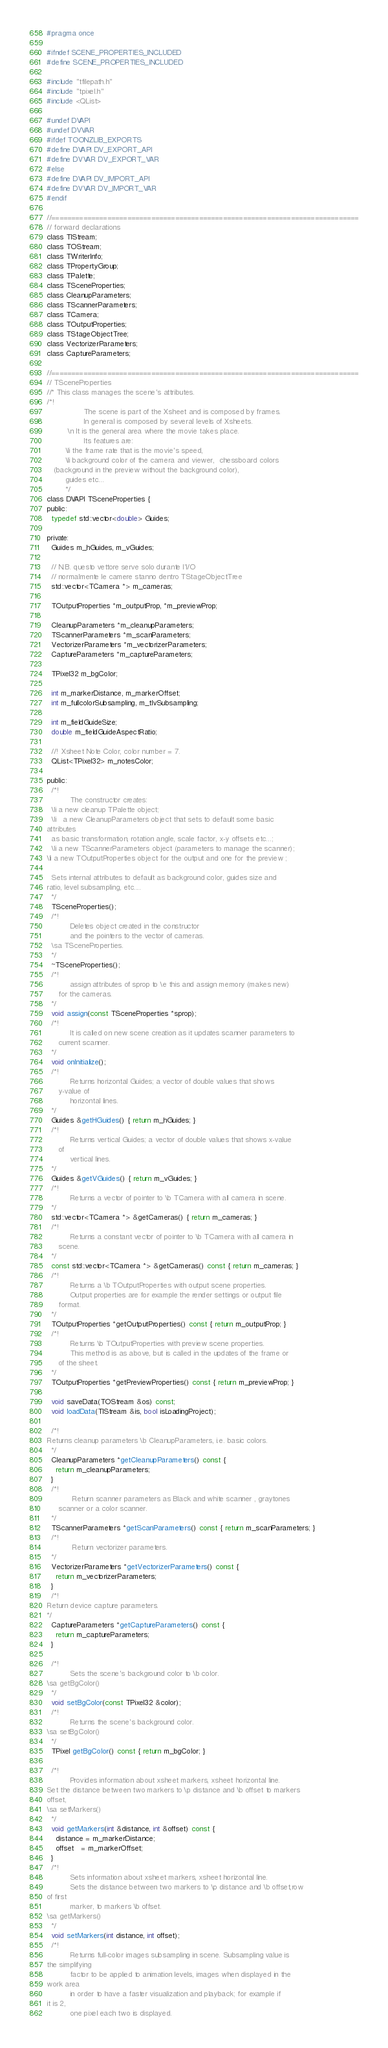Convert code to text. <code><loc_0><loc_0><loc_500><loc_500><_C_>#pragma once

#ifndef SCENE_PROPERTIES_INCLUDED
#define SCENE_PROPERTIES_INCLUDED

#include "tfilepath.h"
#include "tpixel.h"
#include <QList>

#undef DVAPI
#undef DVVAR
#ifdef TOONZLIB_EXPORTS
#define DVAPI DV_EXPORT_API
#define DVVAR DV_EXPORT_VAR
#else
#define DVAPI DV_IMPORT_API
#define DVVAR DV_IMPORT_VAR
#endif

//=============================================================================
// forward declarations
class TIStream;
class TOStream;
class TWriterInfo;
class TPropertyGroup;
class TPalette;
class TSceneProperties;
class CleanupParameters;
class TScannerParameters;
class TCamera;
class TOutputProperties;
class TStageObjectTree;
class VectorizerParameters;
class CaptureParameters;

//=============================================================================
// TSceneProperties
//* This class manages the scene's attributes.
/*!
                The scene is part of the Xsheet and is composed by frames.
                In general is composed by several levels of Xsheets.
         \n	It is the general area where the movie takes place.
                Its features are:
        \li the frame rate that is the movie's speed,
        \li background color of the camera and viewer,  chessboard colors
   (background in the preview without the background color),
        guides etc...
        */
class DVAPI TSceneProperties {
public:
  typedef std::vector<double> Guides;

private:
  Guides m_hGuides, m_vGuides;

  // N.B. questo vettore serve solo durante l'I/O
  // normalmente le camere stanno dentro TStageObjectTree
  std::vector<TCamera *> m_cameras;

  TOutputProperties *m_outputProp, *m_previewProp;

  CleanupParameters *m_cleanupParameters;
  TScannerParameters *m_scanParameters;
  VectorizerParameters *m_vectorizerParameters;
  CaptureParameters *m_captureParameters;

  TPixel32 m_bgColor;

  int m_markerDistance, m_markerOffset;
  int m_fullcolorSubsampling, m_tlvSubsampling;

  int m_fieldGuideSize;
  double m_fieldGuideAspectRatio;

  //! Xsheet Note Color, color number = 7.
  QList<TPixel32> m_notesColor;

public:
  /*!
          The constructor creates:
  \li a new cleanup TPalette object;
  \li	a new CleanupParameters object that sets to default some basic
attributes
  as basic transformation, rotation angle, scale factor, x-y offsets etc...;
  \li a new TScannerParameters object (parameters to manage the scanner);
\li a new TOutputProperties object for the output and one for the preview ;

  Sets internal attributes to default as background color, guides size and
ratio, level subsampling, etc....
  */
  TSceneProperties();
  /*!
          Deletes object created in the constructor
          and the pointers to the vector of cameras.
  \sa TSceneProperties.
  */
  ~TSceneProperties();
  /*!
          assign attributes of sprop to \e this and assign memory (makes new)
     for the cameras.
  */
  void assign(const TSceneProperties *sprop);
  /*!
          It is called on new scene creation as it updates scanner parameters to
     current scanner.
  */
  void onInitialize();
  /*!
          Returns horizontal Guides; a vector of double values that shows
     y-value of
          horizontal lines.
  */
  Guides &getHGuides() { return m_hGuides; }
  /*!
          Returns vertical Guides; a vector of double values that shows x-value
     of
          vertical lines.
  */
  Guides &getVGuides() { return m_vGuides; }
  /*!
          Returns a vector of pointer to \b TCamera with all camera in scene.
  */
  std::vector<TCamera *> &getCameras() { return m_cameras; }
  /*!
          Returns a constant vector of pointer to \b TCamera with all camera in
     scene.
  */
  const std::vector<TCamera *> &getCameras() const { return m_cameras; }
  /*!
          Returns a \b TOutputProperties with output scene properties.
          Output properties are for example the render settings or output file
     format.
  */
  TOutputProperties *getOutputProperties() const { return m_outputProp; }
  /*!
          Returns \b TOutputProperties with preview scene properties.
          This method is as above, but is called in the updates of the frame or
     of the sheet.
  */
  TOutputProperties *getPreviewProperties() const { return m_previewProp; }

  void saveData(TOStream &os) const;
  void loadData(TIStream &is, bool isLoadingProject);

  /*!
Returns cleanup parameters \b CleanupParameters, i.e. basic colors.
  */
  CleanupParameters *getCleanupParameters() const {
    return m_cleanupParameters;
  }
  /*!
           Return scanner parameters as Black and white scanner , graytones
     scanner or a color scanner.
  */
  TScannerParameters *getScanParameters() const { return m_scanParameters; }
  /*!
           Return vectorizer parameters.
  */
  VectorizerParameters *getVectorizerParameters() const {
    return m_vectorizerParameters;
  }
  /*!
Return device capture parameters.
*/
  CaptureParameters *getCaptureParameters() const {
    return m_captureParameters;
  }

  /*!
          Sets the scene's background color to \b color.
\sa getBgColor()
  */
  void setBgColor(const TPixel32 &color);
  /*!
          Returns the scene's background color.
\sa setBgColor()
  */
  TPixel getBgColor() const { return m_bgColor; }

  /*!
          Provides information about xsheet markers, xsheet horizontal line.
Set the distance between two markers to \p distance and \b offset to markers
offset,
\sa setMarkers()
  */
  void getMarkers(int &distance, int &offset) const {
    distance = m_markerDistance;
    offset   = m_markerOffset;
  }
  /*!
          Sets information about xsheet markers, xsheet horizontal line.
          Sets the distance between two markers to \p distance and \b offset,row
of first
          marker, to markers \b offset.
\sa getMarkers()
  */
  void setMarkers(int distance, int offset);
  /*!
          Returns full-color images subsampling in scene. Subsampling value is
the simplifying
          factor to be applied to animation levels, images when displayed in the
work area
          in order to have a faster visualization and playback; for example if
it is 2,
          one pixel each two is displayed.</code> 